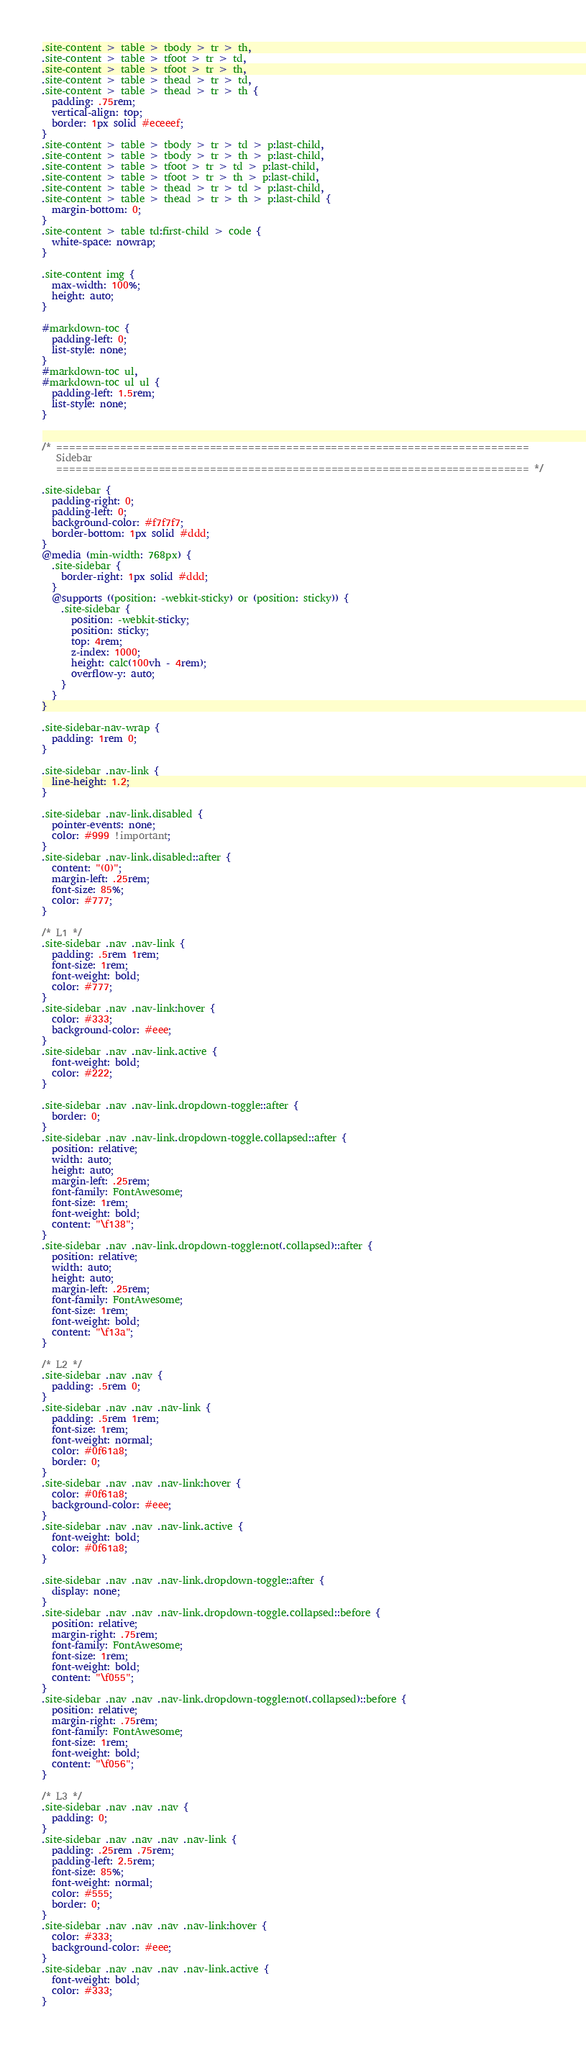<code> <loc_0><loc_0><loc_500><loc_500><_CSS_>.site-content > table > tbody > tr > th,
.site-content > table > tfoot > tr > td,
.site-content > table > tfoot > tr > th,
.site-content > table > thead > tr > td,
.site-content > table > thead > tr > th {
  padding: .75rem;
  vertical-align: top;
  border: 1px solid #eceeef;
}
.site-content > table > tbody > tr > td > p:last-child,
.site-content > table > tbody > tr > th > p:last-child,
.site-content > table > tfoot > tr > td > p:last-child,
.site-content > table > tfoot > tr > th > p:last-child,
.site-content > table > thead > tr > td > p:last-child,
.site-content > table > thead > tr > th > p:last-child {
  margin-bottom: 0;
}
.site-content > table td:first-child > code {
  white-space: nowrap;
}

.site-content img {
  max-width: 100%;
  height: auto;
}

#markdown-toc {
  padding-left: 0;
  list-style: none;
}
#markdown-toc ul,
#markdown-toc ul ul {
  padding-left: 1.5rem;
  list-style: none;
}


/* ==========================================================================
   Sidebar
   ========================================================================== */

.site-sidebar {
  padding-right: 0;
  padding-left: 0;
  background-color: #f7f7f7;
  border-bottom: 1px solid #ddd;
}
@media (min-width: 768px) {
  .site-sidebar {
    border-right: 1px solid #ddd;
  }
  @supports ((position: -webkit-sticky) or (position: sticky)) {
    .site-sidebar {
      position: -webkit-sticky;
      position: sticky;
      top: 4rem;
      z-index: 1000;
      height: calc(100vh - 4rem);
      overflow-y: auto;
    }
  }
}

.site-sidebar-nav-wrap {
  padding: 1rem 0;
}

.site-sidebar .nav-link {
  line-height: 1.2;
}

.site-sidebar .nav-link.disabled {
  pointer-events: none;
  color: #999 !important;
}
.site-sidebar .nav-link.disabled::after {
  content: "(0)";
  margin-left: .25rem;
  font-size: 85%;
  color: #777;
}

/* L1 */
.site-sidebar .nav .nav-link {
  padding: .5rem 1rem;
  font-size: 1rem;
  font-weight: bold;
  color: #777;
}
.site-sidebar .nav .nav-link:hover {
  color: #333;
  background-color: #eee;
}
.site-sidebar .nav .nav-link.active {
  font-weight: bold;
  color: #222;
}

.site-sidebar .nav .nav-link.dropdown-toggle::after {
  border: 0;
}
.site-sidebar .nav .nav-link.dropdown-toggle.collapsed::after {
  position: relative;
  width: auto;
  height: auto;
  margin-left: .25rem;
  font-family: FontAwesome;
  font-size: 1rem;
  font-weight: bold;
  content: "\f138";
}
.site-sidebar .nav .nav-link.dropdown-toggle:not(.collapsed)::after {
  position: relative;
  width: auto;
  height: auto;
  margin-left: .25rem;
  font-family: FontAwesome;
  font-size: 1rem;
  font-weight: bold;
  content: "\f13a";
}

/* L2 */
.site-sidebar .nav .nav {
  padding: .5rem 0;
}
.site-sidebar .nav .nav .nav-link {
  padding: .5rem 1rem;
  font-size: 1rem;
  font-weight: normal;
  color: #0f61a8;
  border: 0;
}
.site-sidebar .nav .nav .nav-link:hover {
  color: #0f61a8;
  background-color: #eee;
}
.site-sidebar .nav .nav .nav-link.active {
  font-weight: bold;
  color: #0f61a8;
}

.site-sidebar .nav .nav .nav-link.dropdown-toggle::after {
  display: none;
}
.site-sidebar .nav .nav .nav-link.dropdown-toggle.collapsed::before {
  position: relative;
  margin-right: .75rem;
  font-family: FontAwesome;
  font-size: 1rem;
  font-weight: bold;
  content: "\f055";
}
.site-sidebar .nav .nav .nav-link.dropdown-toggle:not(.collapsed)::before {
  position: relative;
  margin-right: .75rem;
  font-family: FontAwesome;
  font-size: 1rem;
  font-weight: bold;
  content: "\f056";
}

/* L3 */
.site-sidebar .nav .nav .nav {
  padding: 0;
}
.site-sidebar .nav .nav .nav .nav-link {
  padding: .25rem .75rem;
  padding-left: 2.5rem;
  font-size: 85%;
  font-weight: normal;
  color: #555;
  border: 0;
}
.site-sidebar .nav .nav .nav .nav-link:hover {
  color: #333;
  background-color: #eee;
}
.site-sidebar .nav .nav .nav .nav-link.active {
  font-weight: bold;
  color: #333;
}
</code> 